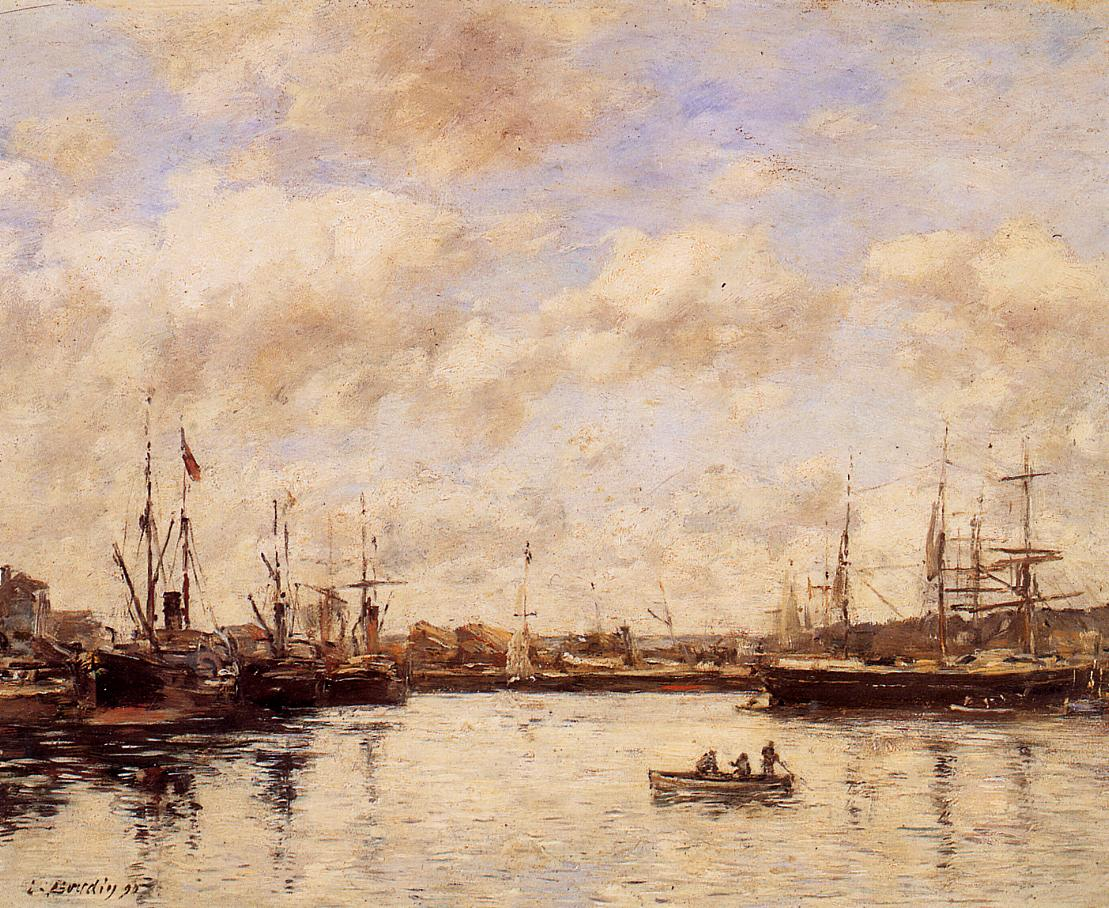What emotions does this painting evoke for you? This painting evokes a sense of tranquility and calmness. The serene color palette and gentle brushstrokes suggest a peaceful, quiet moment. The reflective water and soft sky further enhance the feeling of stillness, making the viewer feel almost as if they are gazing out over the harbor in person, lost in their thoughts. The use of muted colors is quite striking. How does it impact the overall atmosphere? The use of muted colors significantly contributes to the tranquil and serene atmosphere of the painting. These subdued tones prevent any single element from overwhelming the scene, allowing the viewer to take in the entire view as a cohesive, calming whole. The muted palette creates a soft, dreamlike quality, enhancing the peaceful mood and inviting contemplation. Imagine this harbor at night. What do you think it would look like? Imagine the harbor under the soft glow of moonlight. The outlines of the ships and boats would be faintly illuminated, casting gentle reflections on the still water. The previously muted colors would appear even softer, almost blending into the night. Stars would dot the dark sky, complemented by the occasional flicker of lanterns on some of the ships, adding a touch of warmth and life to the otherwise calm and serene nighttime scene. 